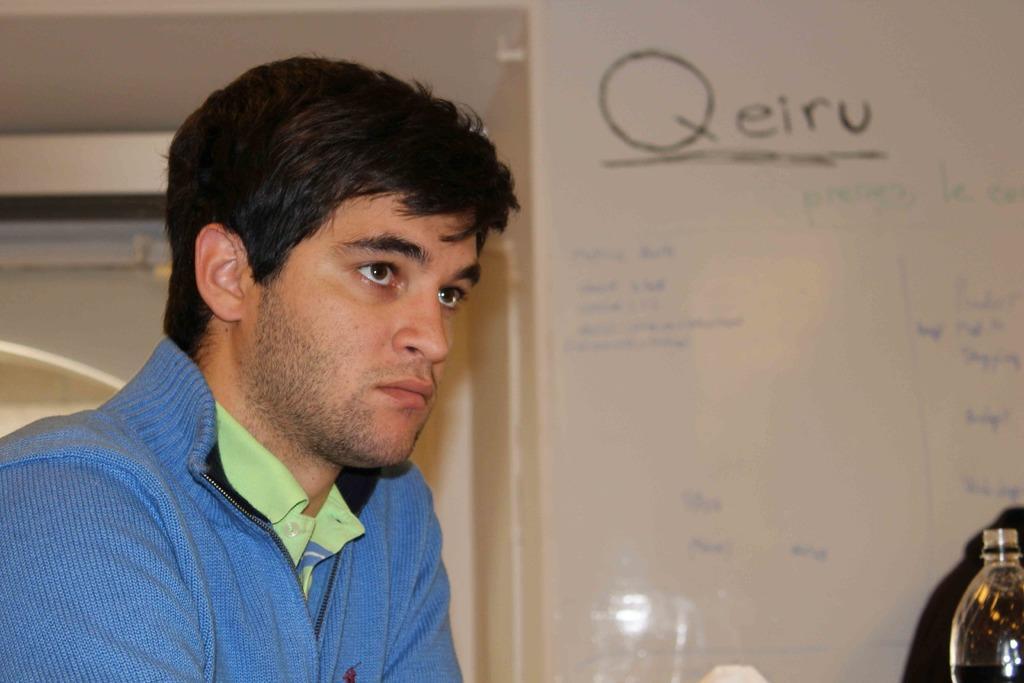Please provide a concise description of this image. A man sitting at a table is looking at something. 